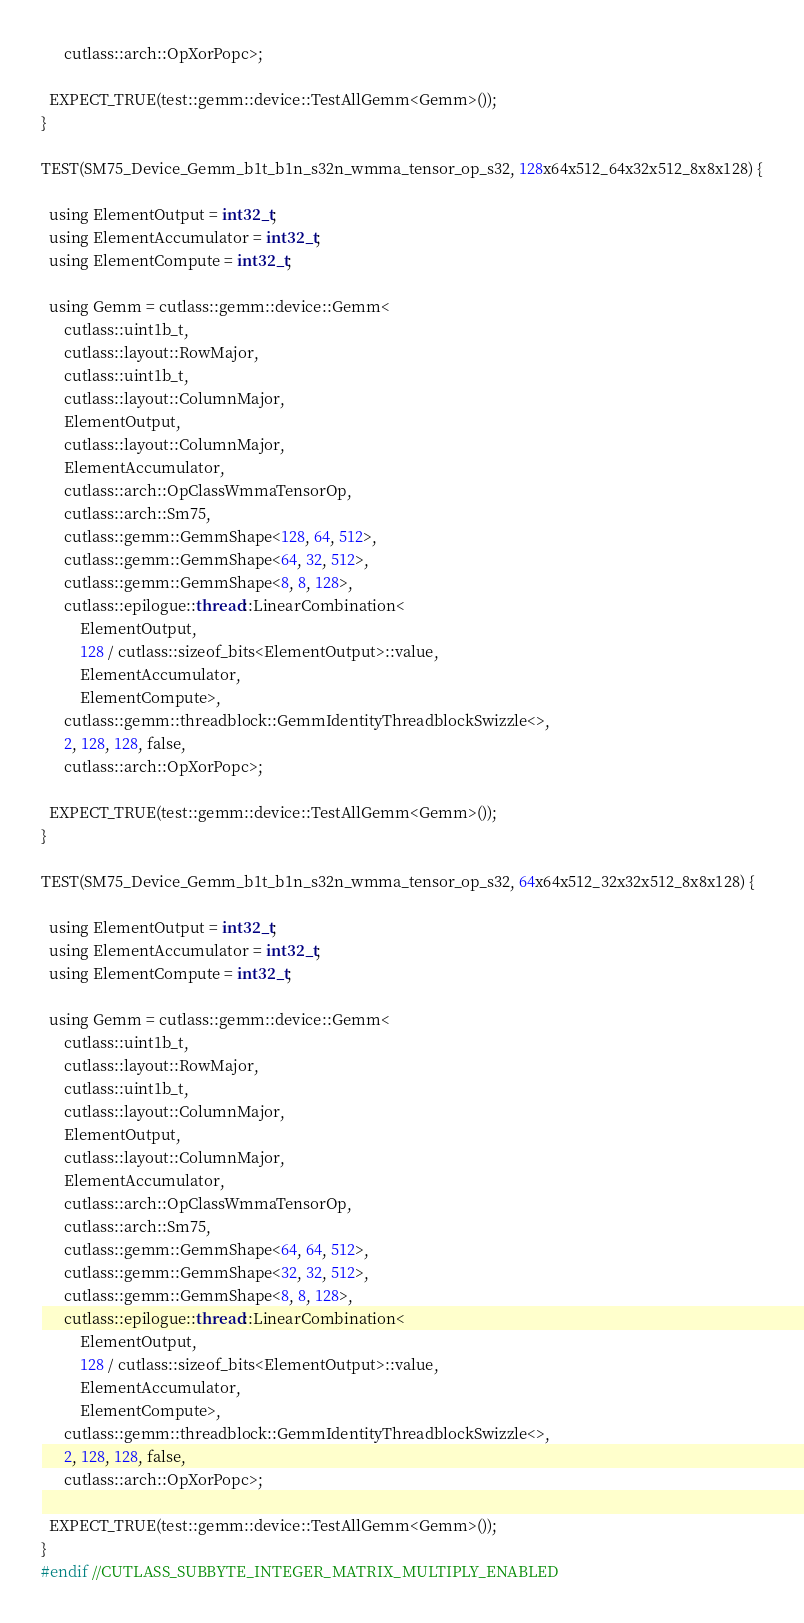Convert code to text. <code><loc_0><loc_0><loc_500><loc_500><_Cuda_>      cutlass::arch::OpXorPopc>;

  EXPECT_TRUE(test::gemm::device::TestAllGemm<Gemm>());
}

TEST(SM75_Device_Gemm_b1t_b1n_s32n_wmma_tensor_op_s32, 128x64x512_64x32x512_8x8x128) {

  using ElementOutput = int32_t;
  using ElementAccumulator = int32_t;
  using ElementCompute = int32_t;

  using Gemm = cutlass::gemm::device::Gemm<
      cutlass::uint1b_t, 
      cutlass::layout::RowMajor, 
      cutlass::uint1b_t,
      cutlass::layout::ColumnMajor, 
      ElementOutput, 
      cutlass::layout::ColumnMajor,
      ElementAccumulator, 
      cutlass::arch::OpClassWmmaTensorOp, 
      cutlass::arch::Sm75,
      cutlass::gemm::GemmShape<128, 64, 512>,
      cutlass::gemm::GemmShape<64, 32, 512>,
      cutlass::gemm::GemmShape<8, 8, 128>,
      cutlass::epilogue::thread::LinearCombination<
          ElementOutput, 
          128 / cutlass::sizeof_bits<ElementOutput>::value,
          ElementAccumulator, 
          ElementCompute>,
      cutlass::gemm::threadblock::GemmIdentityThreadblockSwizzle<>, 
      2, 128, 128, false, 
      cutlass::arch::OpXorPopc>;

  EXPECT_TRUE(test::gemm::device::TestAllGemm<Gemm>());
}

TEST(SM75_Device_Gemm_b1t_b1n_s32n_wmma_tensor_op_s32, 64x64x512_32x32x512_8x8x128) {

  using ElementOutput = int32_t;
  using ElementAccumulator = int32_t;
  using ElementCompute = int32_t;

  using Gemm = cutlass::gemm::device::Gemm<
      cutlass::uint1b_t, 
      cutlass::layout::RowMajor, 
      cutlass::uint1b_t,
      cutlass::layout::ColumnMajor, 
      ElementOutput, 
      cutlass::layout::ColumnMajor,
      ElementAccumulator, 
      cutlass::arch::OpClassWmmaTensorOp, 
      cutlass::arch::Sm75,
      cutlass::gemm::GemmShape<64, 64, 512>,
      cutlass::gemm::GemmShape<32, 32, 512>,
      cutlass::gemm::GemmShape<8, 8, 128>,
      cutlass::epilogue::thread::LinearCombination<
          ElementOutput, 
          128 / cutlass::sizeof_bits<ElementOutput>::value,
          ElementAccumulator, 
          ElementCompute>,
      cutlass::gemm::threadblock::GemmIdentityThreadblockSwizzle<>, 
      2, 128, 128, false, 
      cutlass::arch::OpXorPopc>;

  EXPECT_TRUE(test::gemm::device::TestAllGemm<Gemm>());
}
#endif //CUTLASS_SUBBYTE_INTEGER_MATRIX_MULTIPLY_ENABLED
</code> 